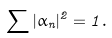<formula> <loc_0><loc_0><loc_500><loc_500>\sum | \alpha _ { n } | ^ { 2 } = 1 .</formula> 